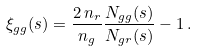<formula> <loc_0><loc_0><loc_500><loc_500>\xi _ { g g } ( s ) = \frac { 2 \, n _ { r } } { n _ { g } } \frac { N _ { g g } ( s ) } { N _ { g r } ( s ) } - 1 \, .</formula> 